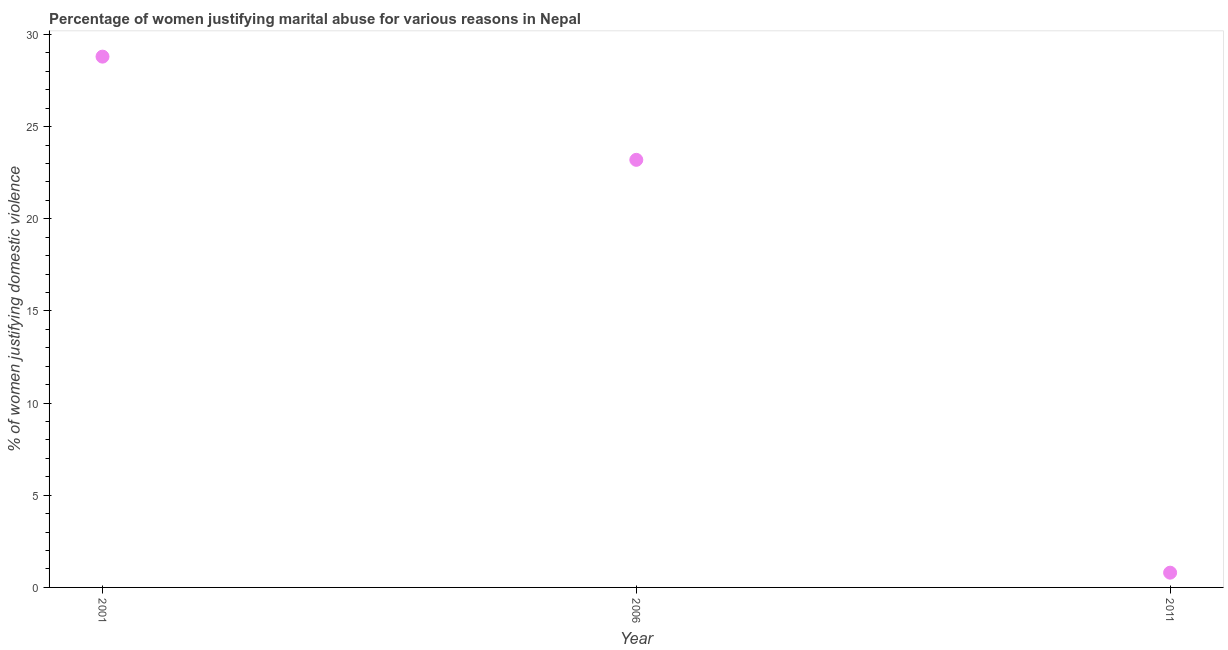What is the percentage of women justifying marital abuse in 2006?
Keep it short and to the point. 23.2. Across all years, what is the maximum percentage of women justifying marital abuse?
Provide a short and direct response. 28.8. Across all years, what is the minimum percentage of women justifying marital abuse?
Make the answer very short. 0.8. In which year was the percentage of women justifying marital abuse maximum?
Offer a very short reply. 2001. What is the sum of the percentage of women justifying marital abuse?
Ensure brevity in your answer.  52.8. What is the difference between the percentage of women justifying marital abuse in 2006 and 2011?
Ensure brevity in your answer.  22.4. What is the average percentage of women justifying marital abuse per year?
Offer a very short reply. 17.6. What is the median percentage of women justifying marital abuse?
Ensure brevity in your answer.  23.2. Do a majority of the years between 2001 and 2011 (inclusive) have percentage of women justifying marital abuse greater than 25 %?
Offer a very short reply. No. What is the ratio of the percentage of women justifying marital abuse in 2006 to that in 2011?
Your answer should be very brief. 29. Is the percentage of women justifying marital abuse in 2006 less than that in 2011?
Ensure brevity in your answer.  No. Is the difference between the percentage of women justifying marital abuse in 2001 and 2006 greater than the difference between any two years?
Your answer should be very brief. No. What is the difference between the highest and the second highest percentage of women justifying marital abuse?
Your answer should be very brief. 5.6. Is the sum of the percentage of women justifying marital abuse in 2001 and 2011 greater than the maximum percentage of women justifying marital abuse across all years?
Make the answer very short. Yes. In how many years, is the percentage of women justifying marital abuse greater than the average percentage of women justifying marital abuse taken over all years?
Provide a succinct answer. 2. How many dotlines are there?
Your answer should be compact. 1. How many years are there in the graph?
Make the answer very short. 3. Are the values on the major ticks of Y-axis written in scientific E-notation?
Your response must be concise. No. Does the graph contain grids?
Give a very brief answer. No. What is the title of the graph?
Give a very brief answer. Percentage of women justifying marital abuse for various reasons in Nepal. What is the label or title of the Y-axis?
Ensure brevity in your answer.  % of women justifying domestic violence. What is the % of women justifying domestic violence in 2001?
Your answer should be compact. 28.8. What is the % of women justifying domestic violence in 2006?
Ensure brevity in your answer.  23.2. What is the difference between the % of women justifying domestic violence in 2001 and 2011?
Your response must be concise. 28. What is the difference between the % of women justifying domestic violence in 2006 and 2011?
Your response must be concise. 22.4. What is the ratio of the % of women justifying domestic violence in 2001 to that in 2006?
Provide a succinct answer. 1.24. 